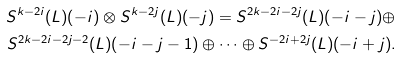<formula> <loc_0><loc_0><loc_500><loc_500>S ^ { k - 2 i } ( \L L ) ( - i ) \otimes S ^ { k - 2 j } ( \L L ) ( - j ) = S ^ { 2 k - 2 i - 2 j } ( \L L ) ( - i - j ) \oplus \\ S ^ { 2 k - 2 i - 2 j - 2 } ( \L L ) ( - i - j - 1 ) \oplus \cdots \oplus S ^ { - 2 i + 2 j } ( \L L ) ( - i + j ) .</formula> 